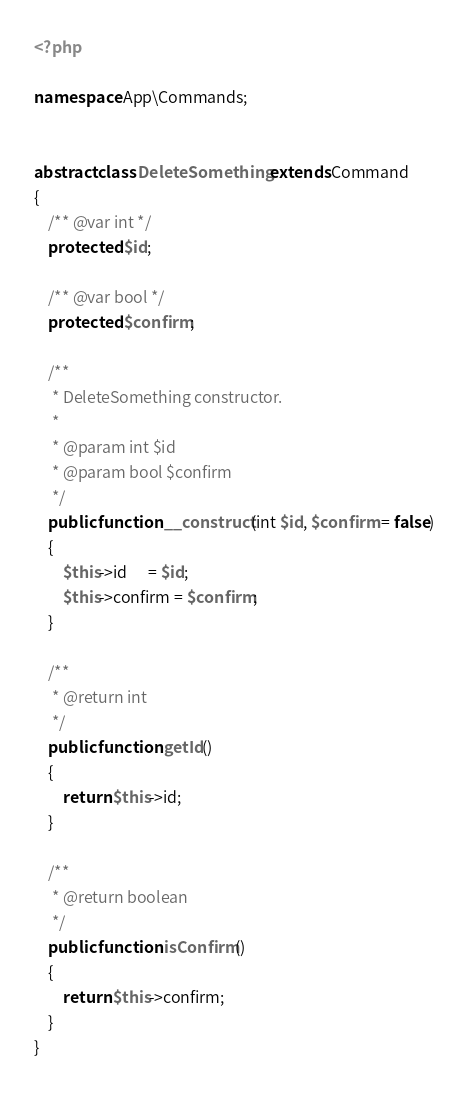<code> <loc_0><loc_0><loc_500><loc_500><_PHP_><?php

namespace App\Commands;


abstract class DeleteSomething extends Command
{
    /** @var int */
    protected $id;

    /** @var bool */
    protected $confirm;

    /**
     * DeleteSomething constructor.
     *
     * @param int $id
     * @param bool $confirm
     */
    public function __construct(int $id, $confirm = false)
    {
        $this->id      = $id;
        $this->confirm = $confirm;
    }

    /**
     * @return int
     */
    public function getId()
    {
        return $this->id;
    }

    /**
     * @return boolean
     */
    public function isConfirm()
    {
        return $this->confirm;
    }
}</code> 